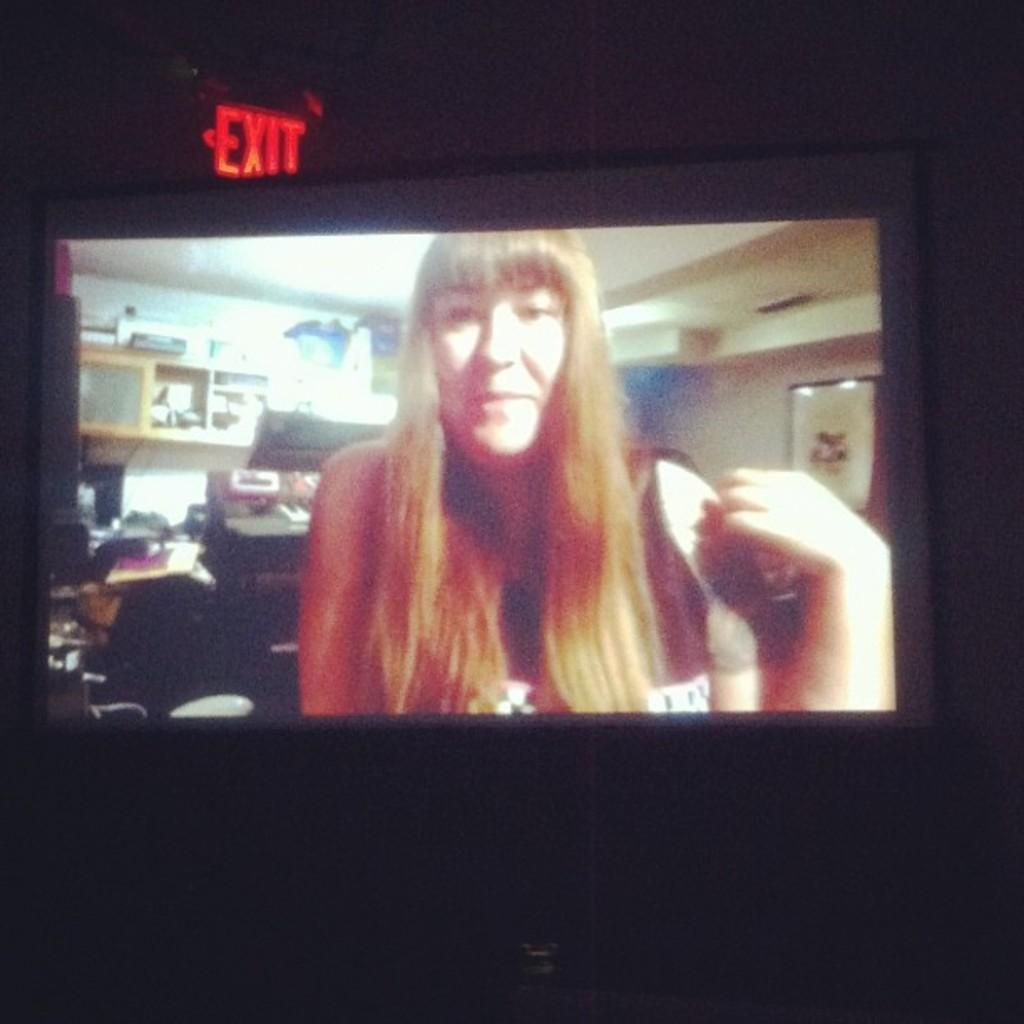<image>
Relay a brief, clear account of the picture shown. A woman with long blond hair and bangs is pictured on a wide screen in front of an exit sign. 